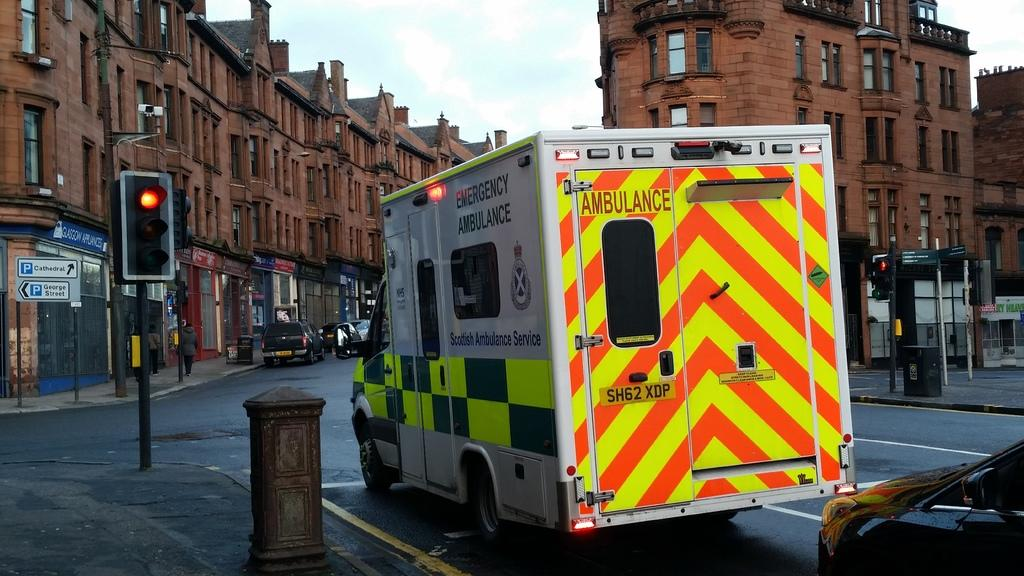What type of vehicle is present in the image? There is an ambulance in the image. What is the car in the image doing? The car is at a signal in the image. What helps regulate traffic in the image? There are traffic lights on poles in the image. What can be seen on the buildings in the image? There are buildings with windows in the image. What is the condition of the sky in the image? The sky is clear in the image. What type of collar is the ambulance wearing in the image? Ambulances do not wear collars; they are vehicles. Who is the partner of the car at the signal in the image? Cars do not have partners; they are inanimate objects. 